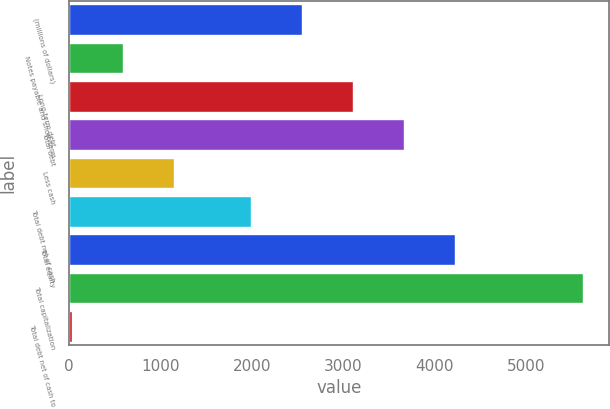<chart> <loc_0><loc_0><loc_500><loc_500><bar_chart><fcel>(millions of dollars)<fcel>Notes payable and short-term<fcel>Long-term debt<fcel>Total debt<fcel>Less cash<fcel>Total debt net of cash<fcel>Total equity<fcel>Total capitalization<fcel>Total debt net of cash to<nl><fcel>2546.85<fcel>593.85<fcel>3105.3<fcel>3663.75<fcel>1152.3<fcel>1988.4<fcel>4222.2<fcel>5619.9<fcel>35.4<nl></chart> 